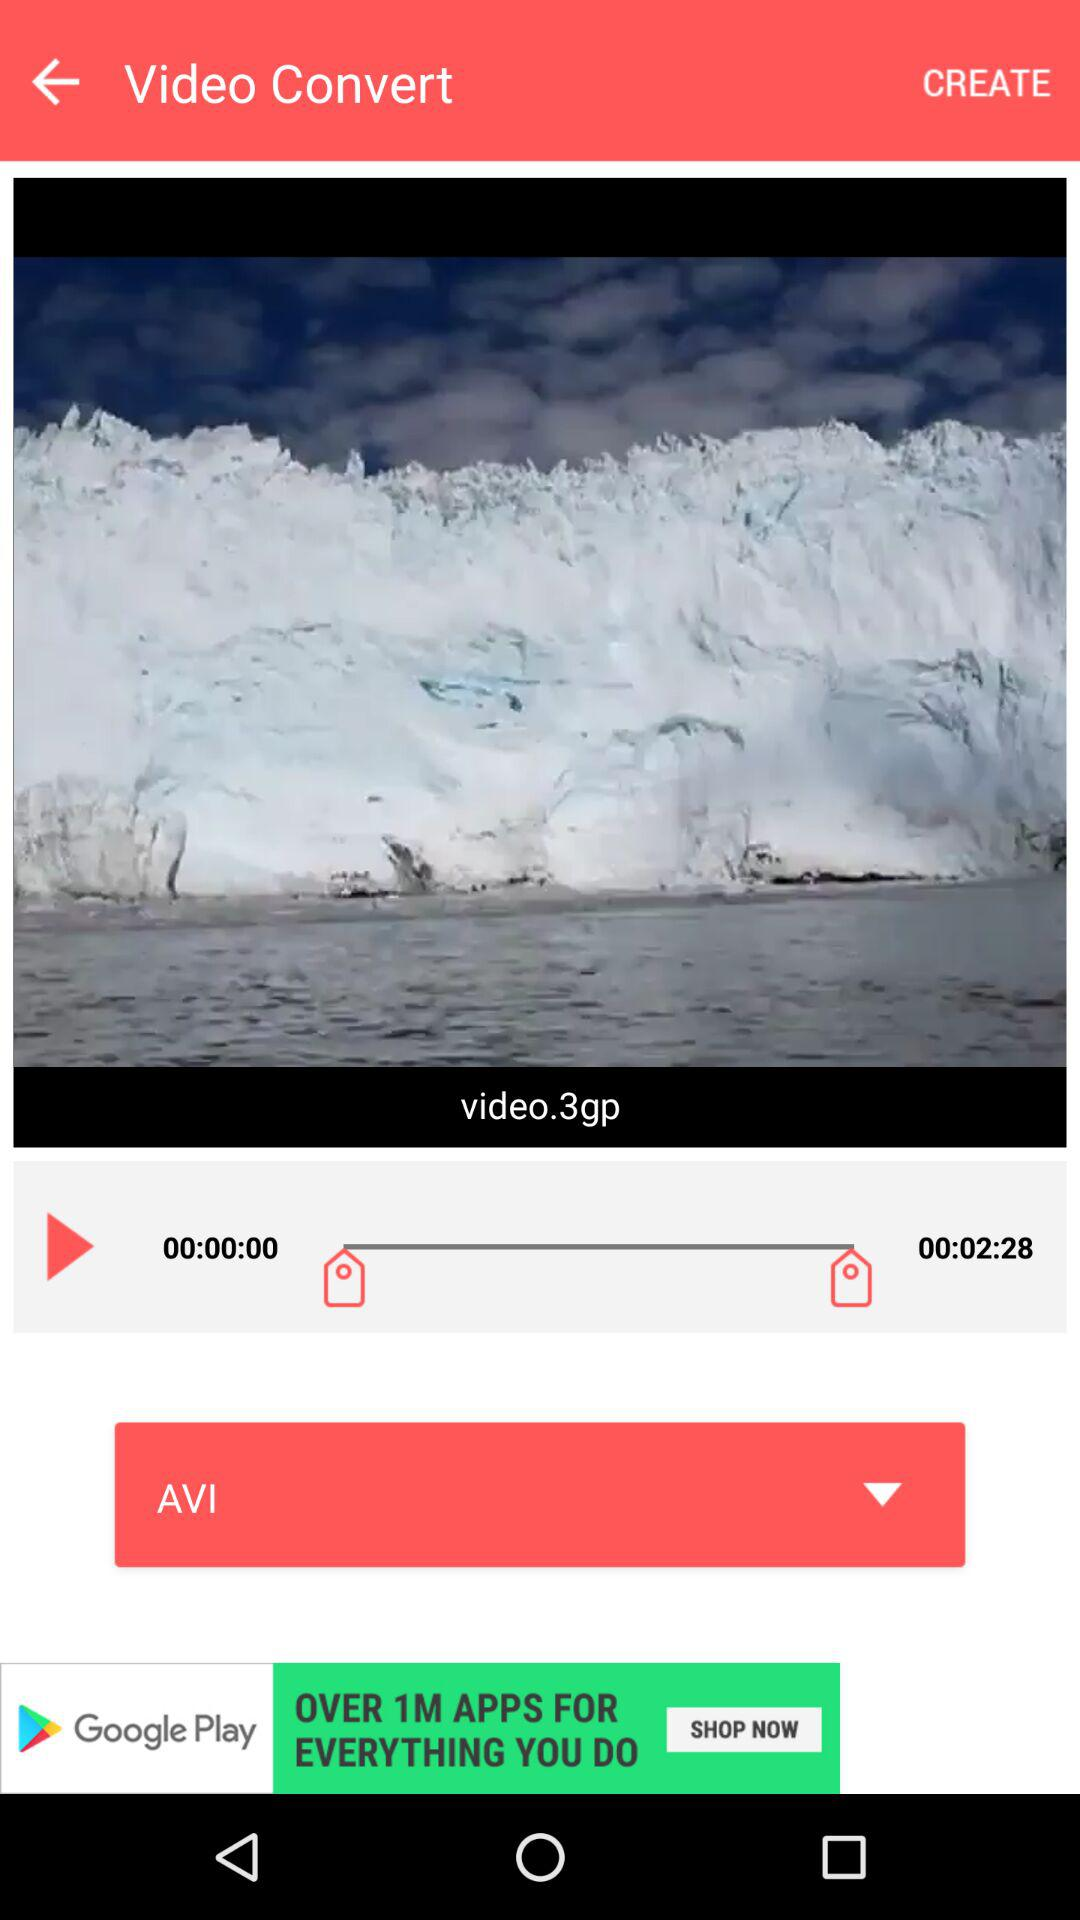What's the duration of the video? The duration of the video is 00:02:28. 